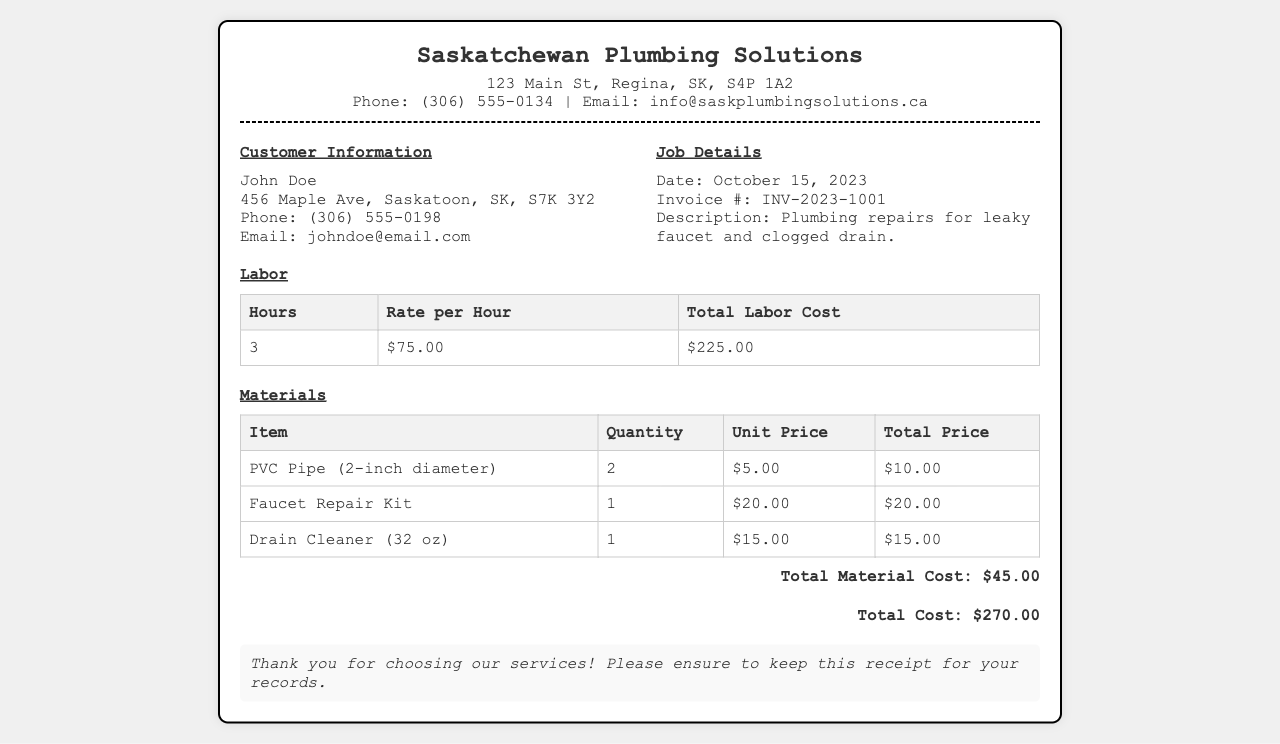What is the company name? The company name is prominently displayed at the top of the receipt.
Answer: Saskatchewan Plumbing Solutions Who is the customer? The customer information section lists the name of the customer.
Answer: John Doe What is the total labor cost? The total labor cost is shown in the labor section of the receipt.
Answer: $225.00 What materials were used? The materials section lists all the items used for the plumbing job.
Answer: PVC Pipe, Faucet Repair Kit, Drain Cleaner What is the invoice number? The invoice number can be found in the job details section of the receipt.
Answer: INV-2023-1001 How many hours of labor were provided? The hours of labor can be found in the labor section of the receipt.
Answer: 3 What is the total cost of the job? The total cost is displayed at the end of the receipt, summarizing all expenses.
Answer: $270.00 When was the service performed? The date of the job is included in the job details section of the receipt.
Answer: October 15, 2023 What is the unit price of the faucet repair kit? The unit price can be found in the materials table for the faucet repair kit.
Answer: $20.00 